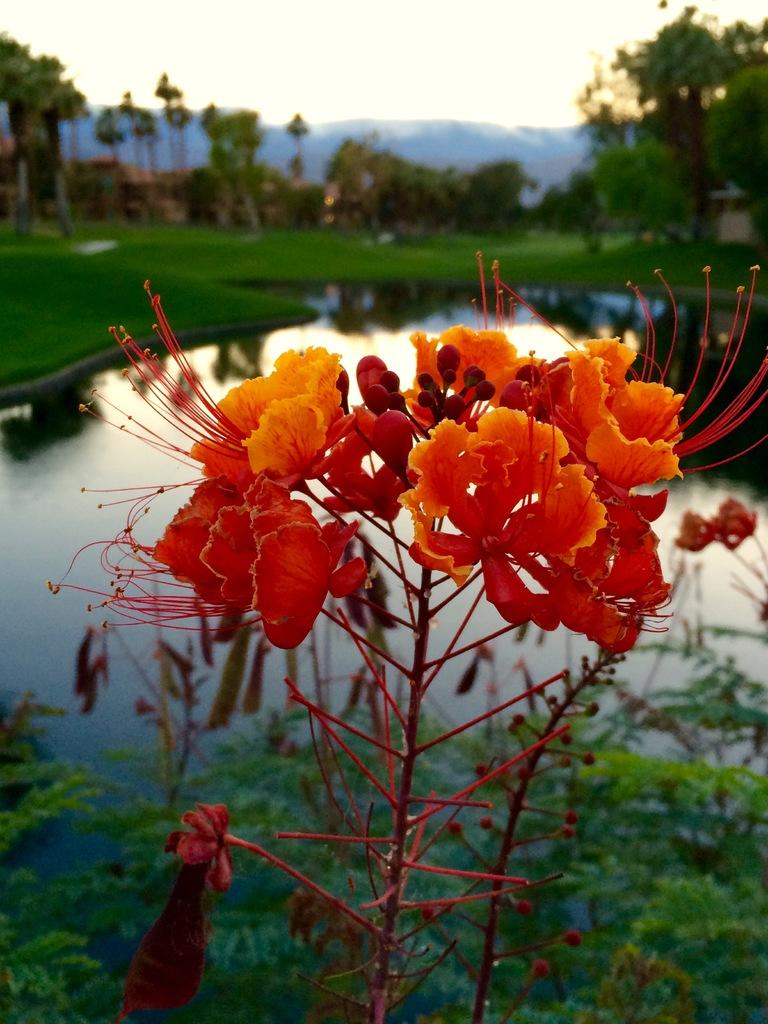What type of plants can be seen in the image? There are plants with flowers and plants with buds in the image. What can be seen in the image besides plants? There is water, grass, trees, hills, and the sky visible in the image. Can you describe the terrain in the image? The image features hills, which suggests a hilly landscape. What is the condition of the sky in the image? The sky is visible in the image, but no specific weather conditions are mentioned. What type of stamp can be seen on the leaves of the plants in the image? There is no stamp present on the leaves of the plants in the image. What knowledge can be gained from studying the plants in the image? The image provides visual information about the plants, but it does not convey any specific knowledge or insights. 